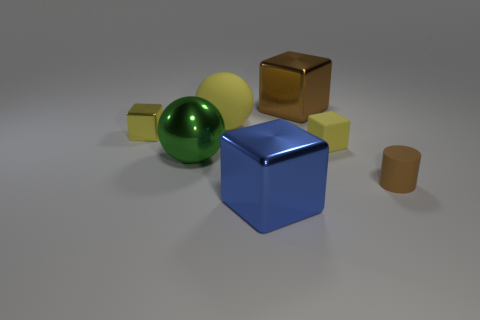Is the small matte block the same color as the big matte thing?
Give a very brief answer. Yes. Are there more blue blocks that are in front of the large brown cube than big yellow matte spheres to the left of the tiny yellow shiny block?
Your answer should be compact. Yes. There is a tiny rubber thing that is behind the small brown thing; does it have the same color as the big rubber ball?
Your response must be concise. Yes. Are there any other things that have the same color as the large rubber sphere?
Ensure brevity in your answer.  Yes. Is the number of large metal things left of the blue metallic block greater than the number of tiny brown metallic spheres?
Offer a terse response. Yes. Is the green sphere the same size as the rubber cube?
Your answer should be compact. No. What is the material of the blue thing that is the same shape as the big brown metal object?
Keep it short and to the point. Metal. Are there any other things that have the same material as the blue cube?
Provide a succinct answer. Yes. What number of brown things are large objects or large cubes?
Your answer should be compact. 1. What is the large block on the right side of the large blue thing made of?
Your answer should be very brief. Metal. 